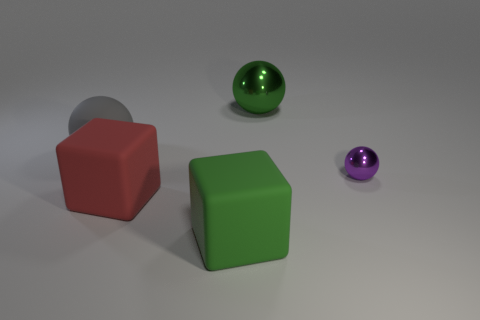Add 5 large green shiny balls. How many objects exist? 10 Subtract all balls. How many objects are left? 2 Add 1 large shiny balls. How many large shiny balls are left? 2 Add 4 large blue cylinders. How many large blue cylinders exist? 4 Subtract 0 blue balls. How many objects are left? 5 Subtract all large green balls. Subtract all gray cubes. How many objects are left? 4 